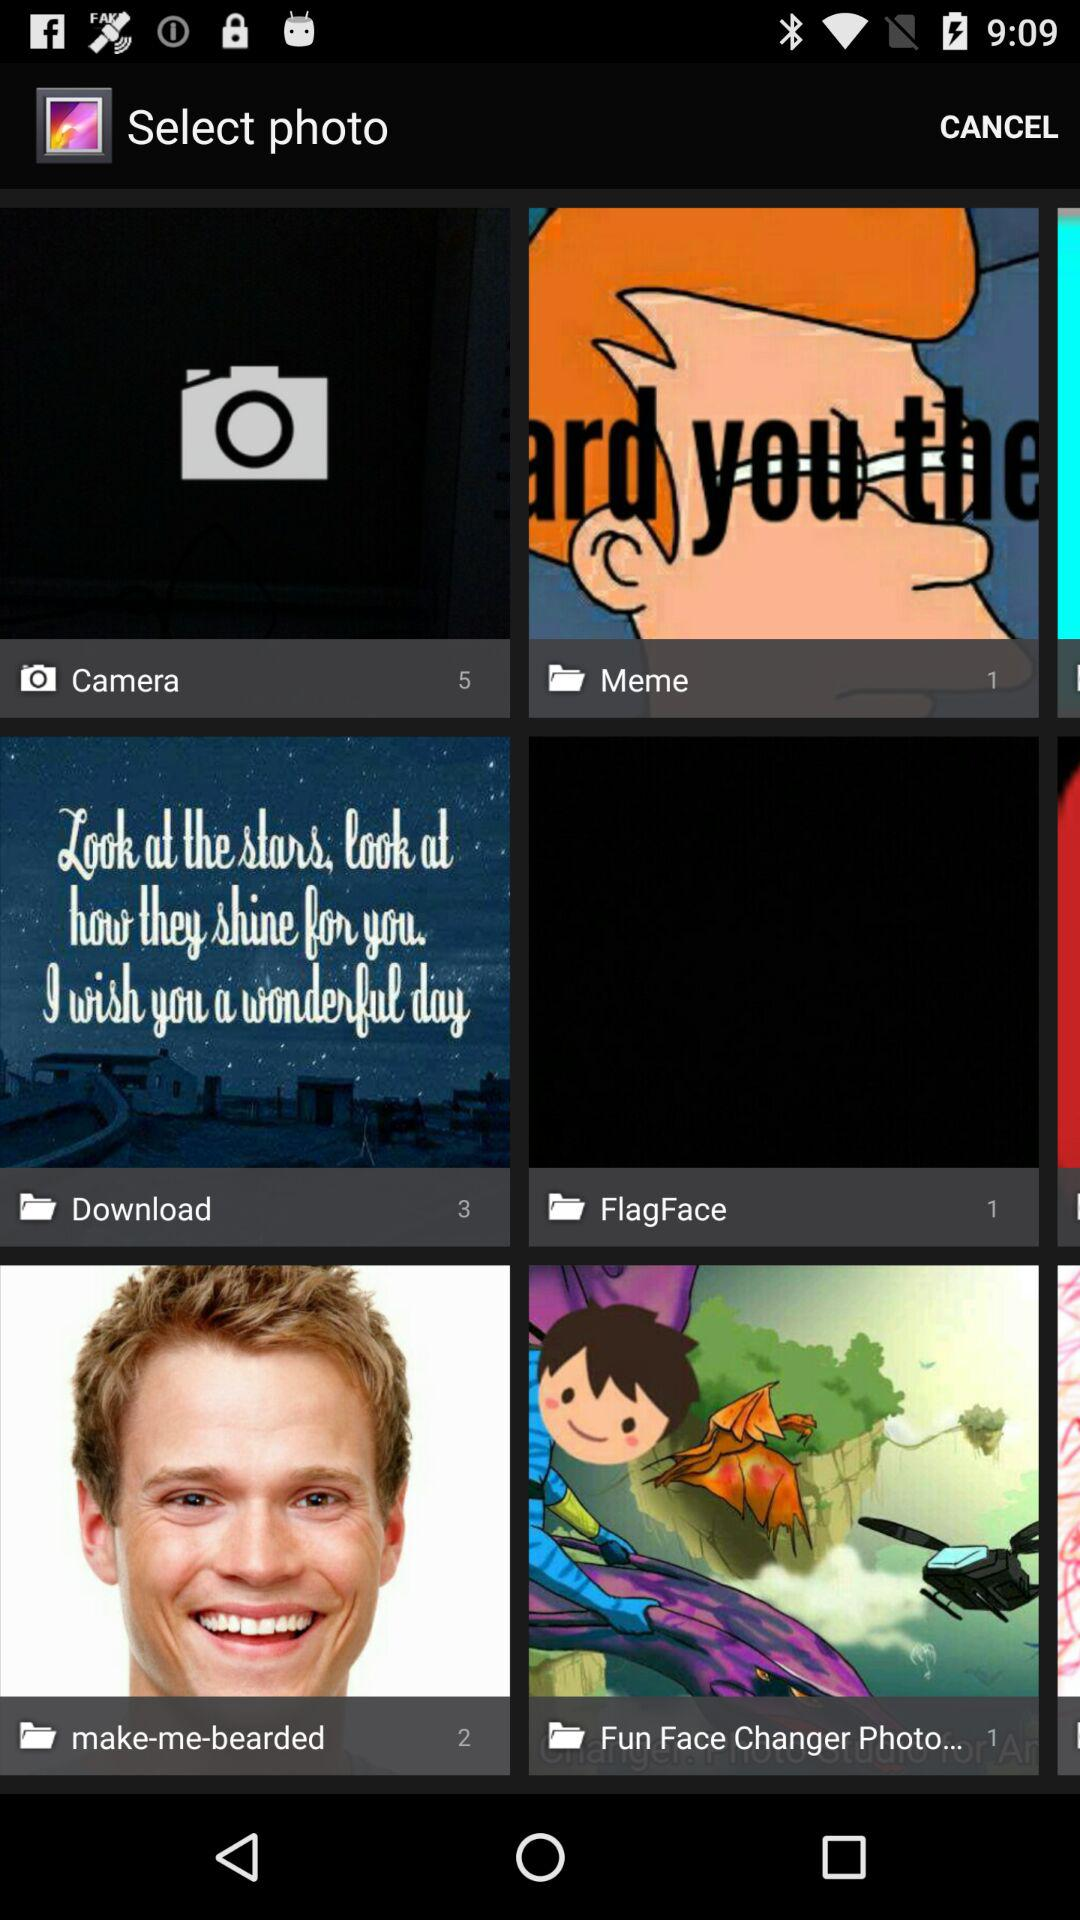How many photos are in the download? There are 3 photos in the download. 